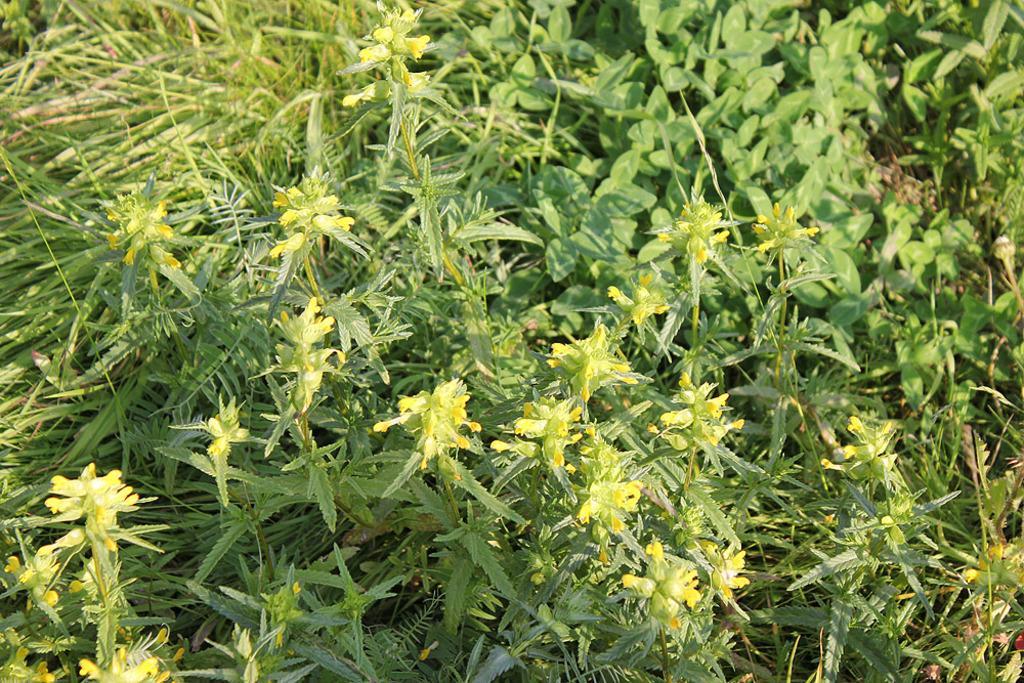How would you summarize this image in a sentence or two? In the picture I can see flowering plants and green grass. 